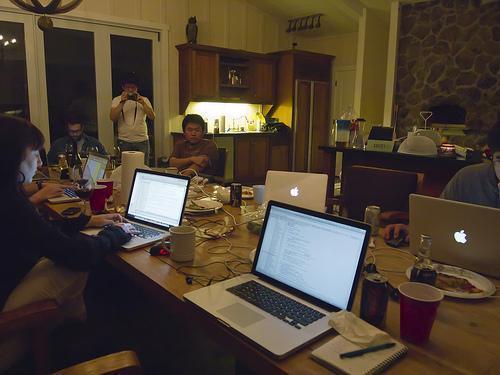How many laptops are visible in the photo?
Give a very brief answer. 5. How many people are in the scene?
Give a very brief answer. 5. 